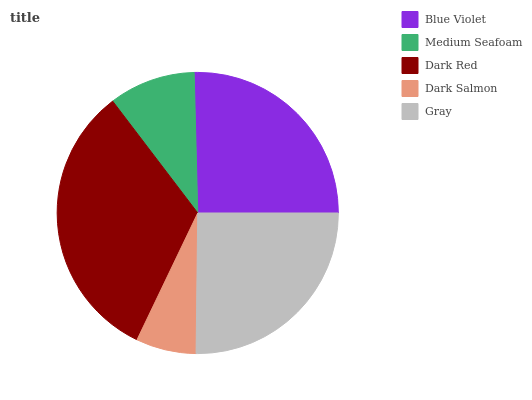Is Dark Salmon the minimum?
Answer yes or no. Yes. Is Dark Red the maximum?
Answer yes or no. Yes. Is Medium Seafoam the minimum?
Answer yes or no. No. Is Medium Seafoam the maximum?
Answer yes or no. No. Is Blue Violet greater than Medium Seafoam?
Answer yes or no. Yes. Is Medium Seafoam less than Blue Violet?
Answer yes or no. Yes. Is Medium Seafoam greater than Blue Violet?
Answer yes or no. No. Is Blue Violet less than Medium Seafoam?
Answer yes or no. No. Is Gray the high median?
Answer yes or no. Yes. Is Gray the low median?
Answer yes or no. Yes. Is Dark Salmon the high median?
Answer yes or no. No. Is Blue Violet the low median?
Answer yes or no. No. 